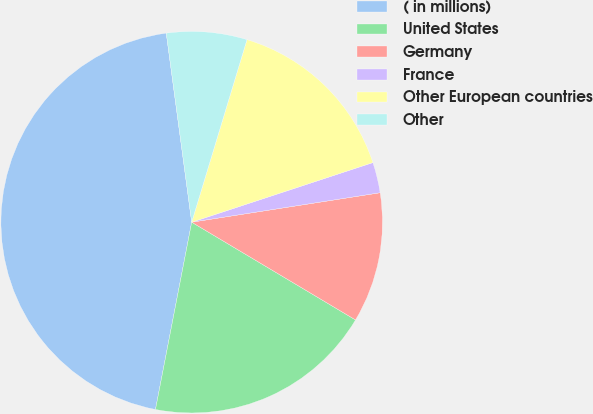Convert chart to OTSL. <chart><loc_0><loc_0><loc_500><loc_500><pie_chart><fcel>( in millions)<fcel>United States<fcel>Germany<fcel>France<fcel>Other European countries<fcel>Other<nl><fcel>44.83%<fcel>19.48%<fcel>11.03%<fcel>2.59%<fcel>15.26%<fcel>6.81%<nl></chart> 